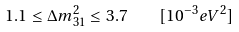Convert formula to latex. <formula><loc_0><loc_0><loc_500><loc_500>1 . 1 \leq \Delta m _ { 3 1 } ^ { 2 } \leq 3 . 7 \quad [ 1 0 ^ { - 3 } e V ^ { 2 } ]</formula> 